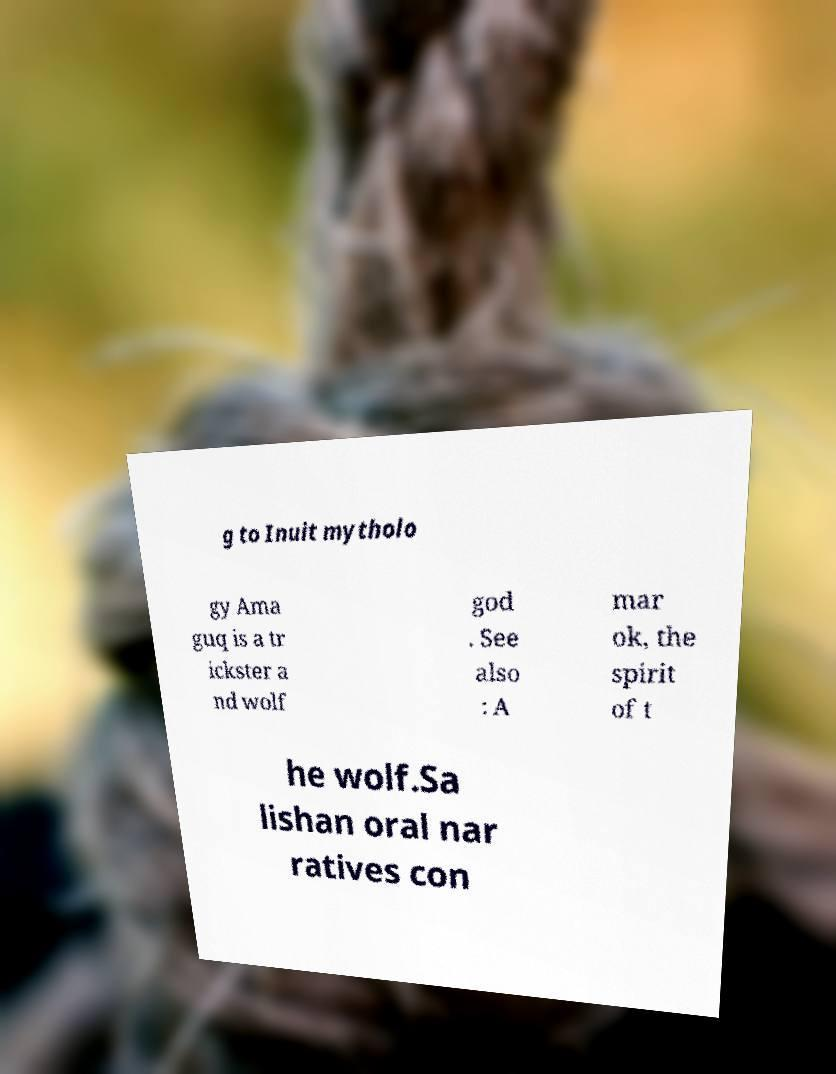Please read and relay the text visible in this image. What does it say? g to Inuit mytholo gy Ama guq is a tr ickster a nd wolf god . See also : A mar ok, the spirit of t he wolf.Sa lishan oral nar ratives con 